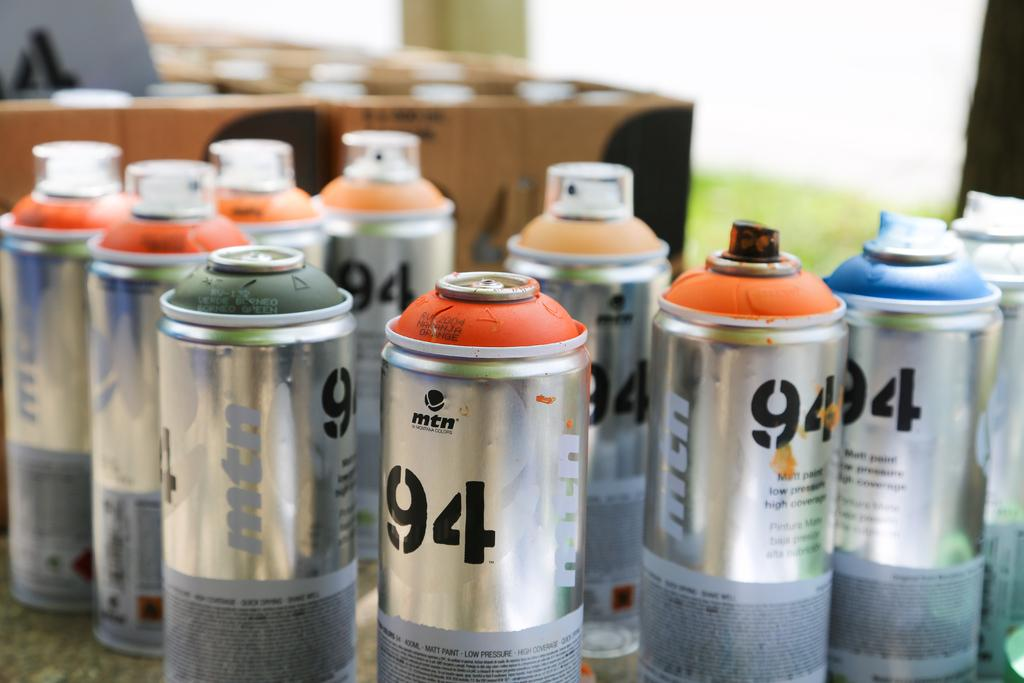<image>
Summarize the visual content of the image. cans of what looks like spray paint, all labeled with the number 94 